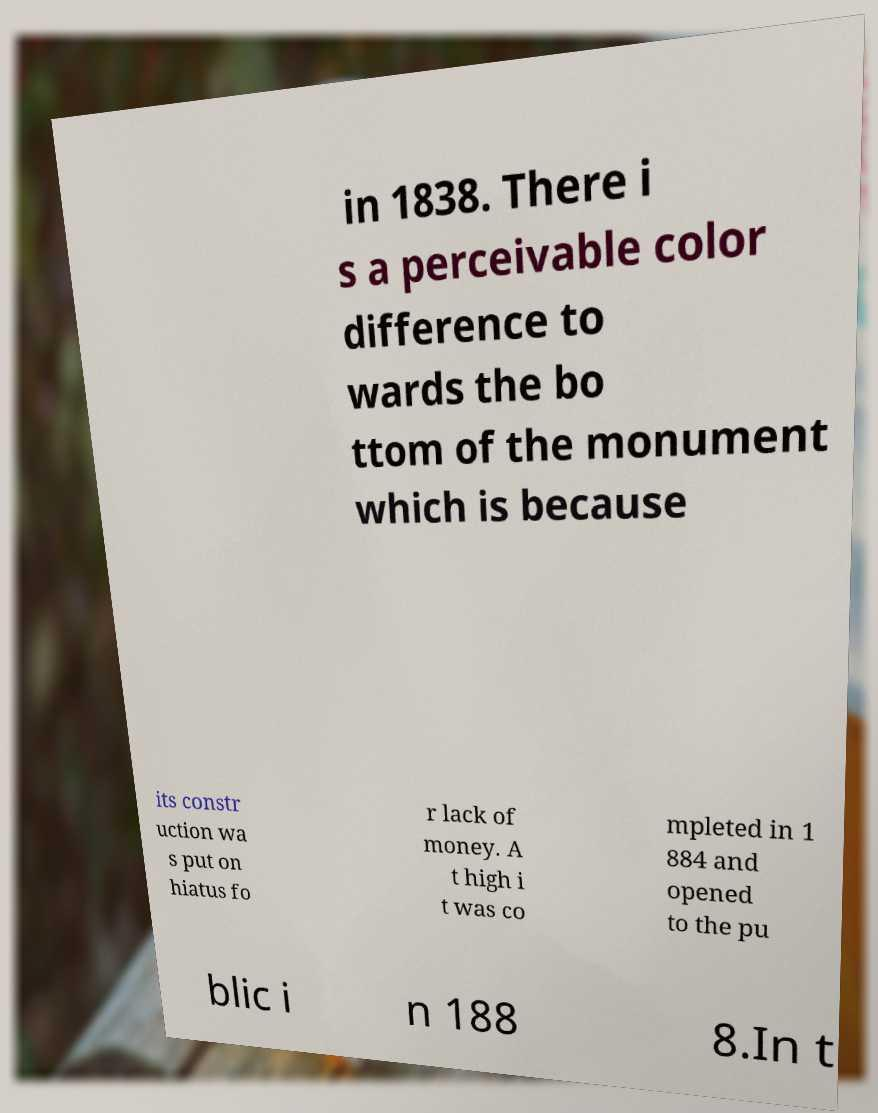Can you accurately transcribe the text from the provided image for me? in 1838. There i s a perceivable color difference to wards the bo ttom of the monument which is because its constr uction wa s put on hiatus fo r lack of money. A t high i t was co mpleted in 1 884 and opened to the pu blic i n 188 8.In t 